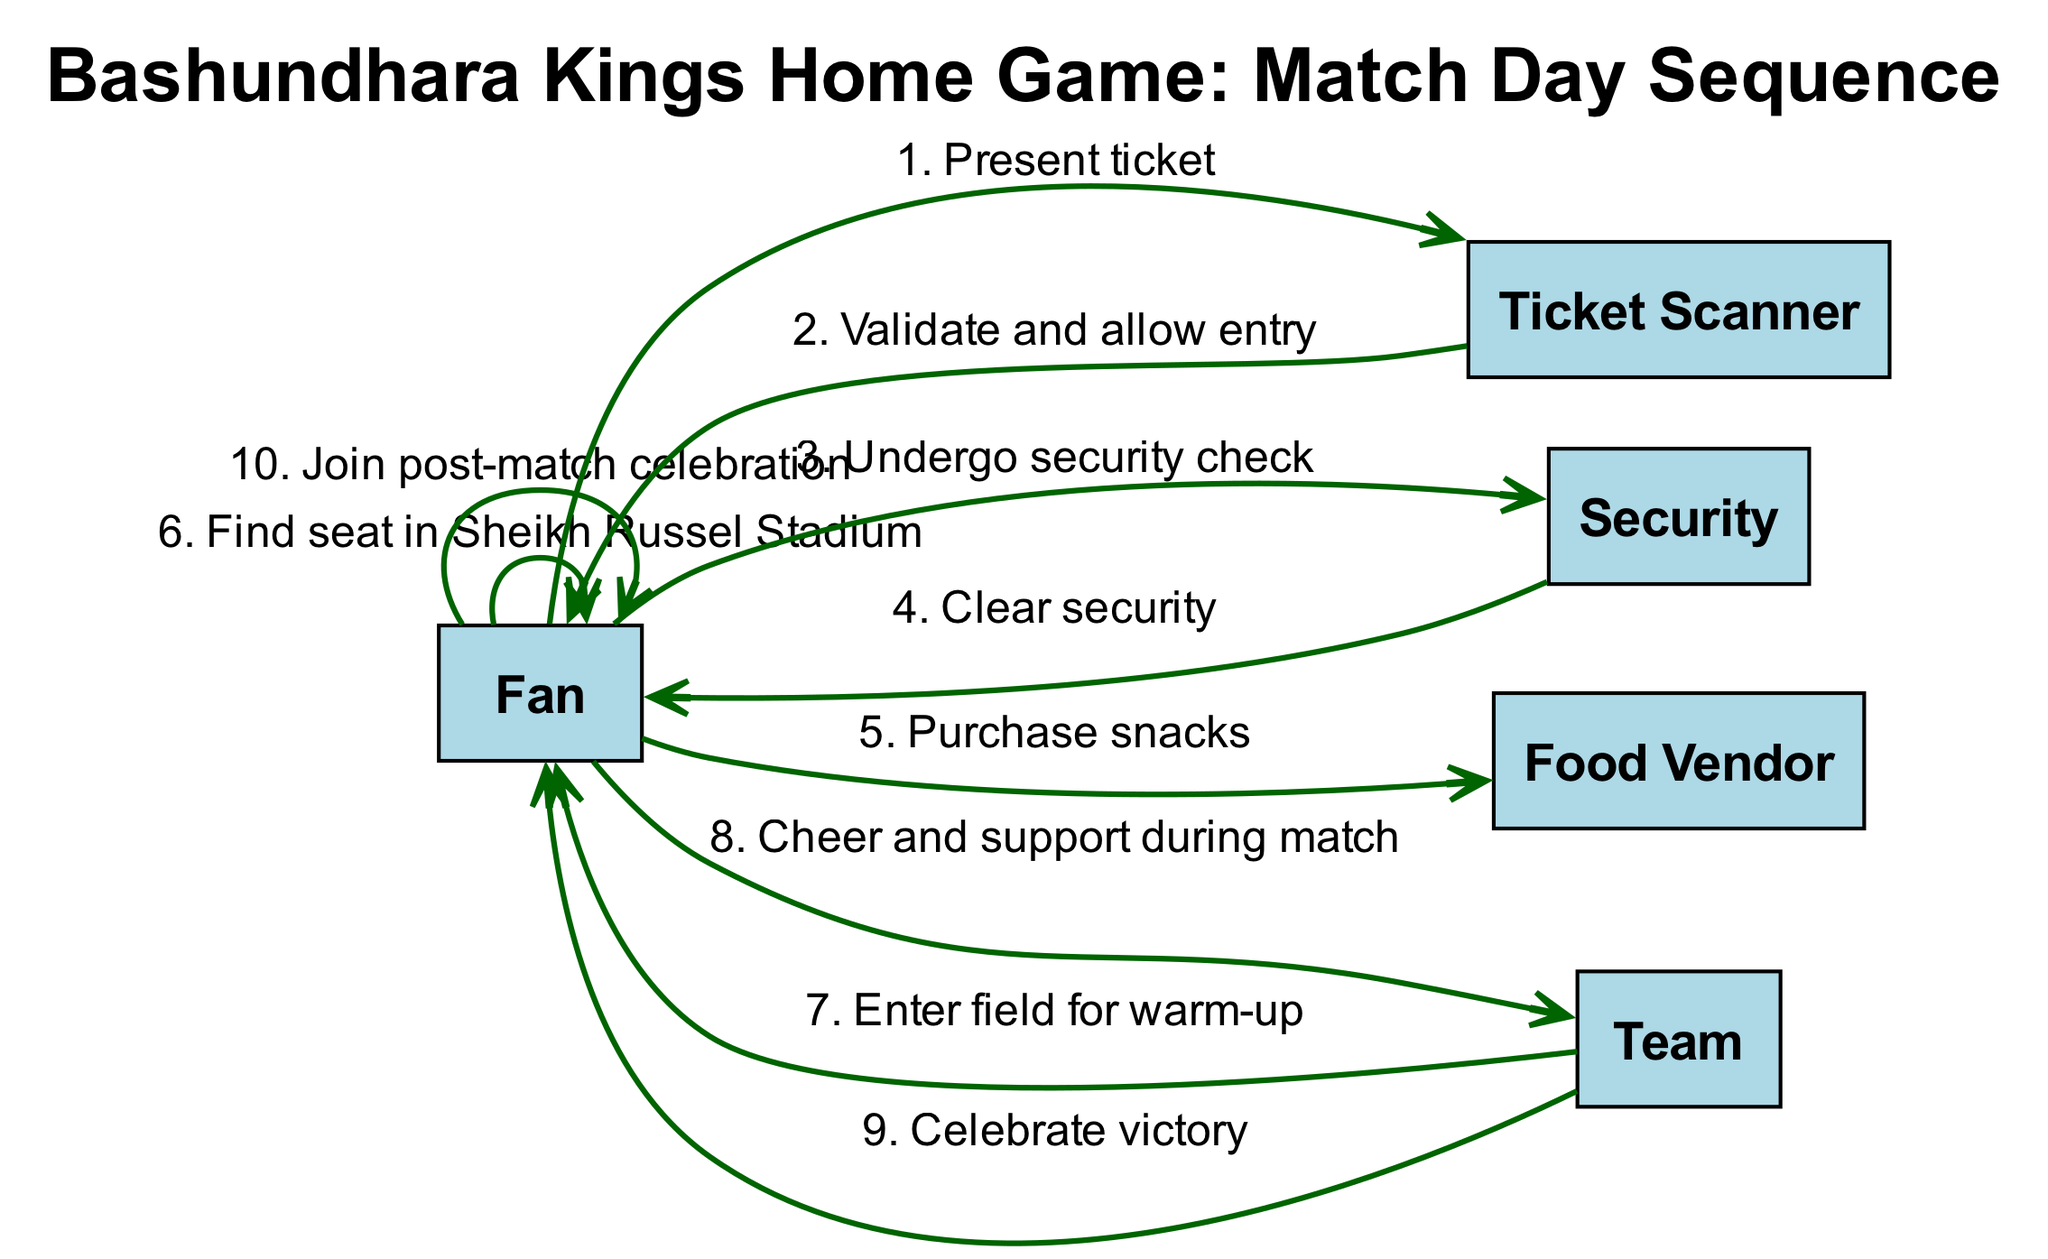What is the first action by the Fan? The first action by the Fan, as indicated in the sequence diagram, is to present their ticket to the Ticket Scanner. This is the initial step that starts the entry process into the stadium for the match.
Answer: Present ticket How many actors are involved in the match day sequence? The diagram lists five distinct actors involved in the match day sequence. These actors are the Fan, Ticket Scanner, Security, Food Vendor, and Team.
Answer: Five What action follows the Fan's purchase of snacks? After purchasing snacks, the Fan's next action is to find a seat in Sheikh Russel Stadium. This indicates that the Fan engages with the venue after obtaining refreshments.
Answer: Find seat in Sheikh Russel Stadium Which action occurs before the Team enters the field for warm-up? The action that occurs before the Team enters the field for warm-up is the Fan finding their seat in the stadium. This sequence indicates that the Fan is settled in before the Team performs their warm-up.
Answer: Find seat in Sheikh Russel Stadium What is the Fan's final action in the sequence? The final action taken by the Fan is to join the post-match celebration, which signifies their participation in the festivities following the Team's victory.
Answer: Join post-match celebration How many actions are performed by the Team in the sequence? The Team performs two distinct actions in the sequence: entering the field for warm-up and celebrating victory. This indicates their involvement both before and after the match.
Answer: Two 